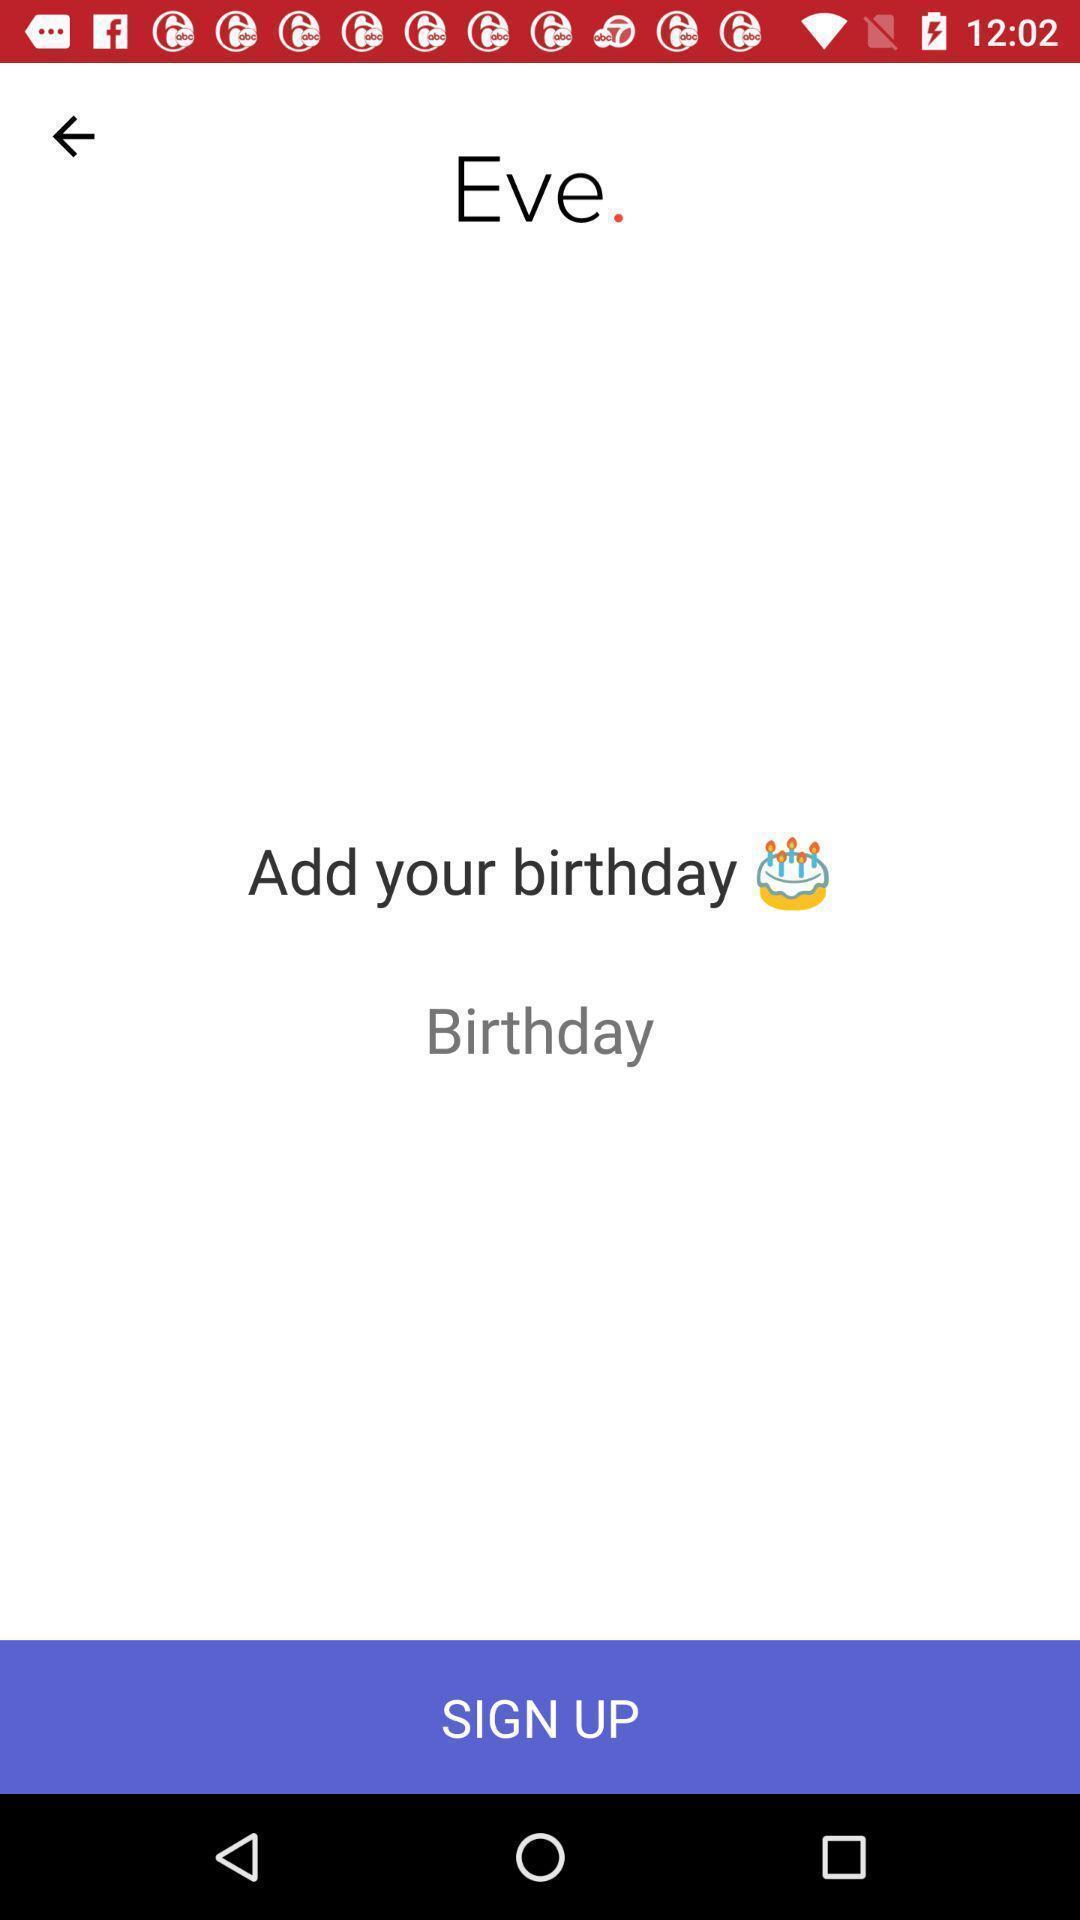Describe the visual elements of this screenshot. Sign up page for adding birthday displayed. 